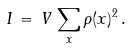Convert formula to latex. <formula><loc_0><loc_0><loc_500><loc_500>I \, = \, V \, \sum _ { x } \rho ( x ) ^ { 2 } \, .</formula> 